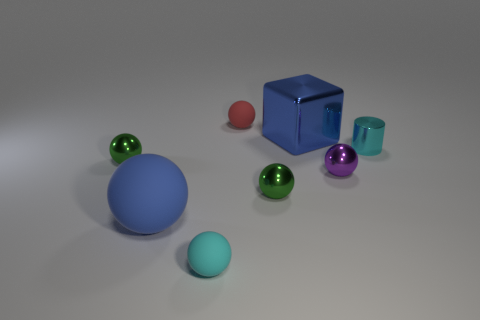Subtract all large blue balls. How many balls are left? 5 Add 1 tiny green objects. How many objects exist? 9 Subtract 1 cylinders. How many cylinders are left? 0 Subtract all balls. How many objects are left? 2 Subtract all green spheres. How many spheres are left? 4 Subtract all brown balls. Subtract all purple blocks. How many balls are left? 6 Subtract all cyan cubes. How many cyan spheres are left? 1 Subtract all metal balls. Subtract all small cyan balls. How many objects are left? 4 Add 7 big rubber objects. How many big rubber objects are left? 8 Add 6 gray metallic balls. How many gray metallic balls exist? 6 